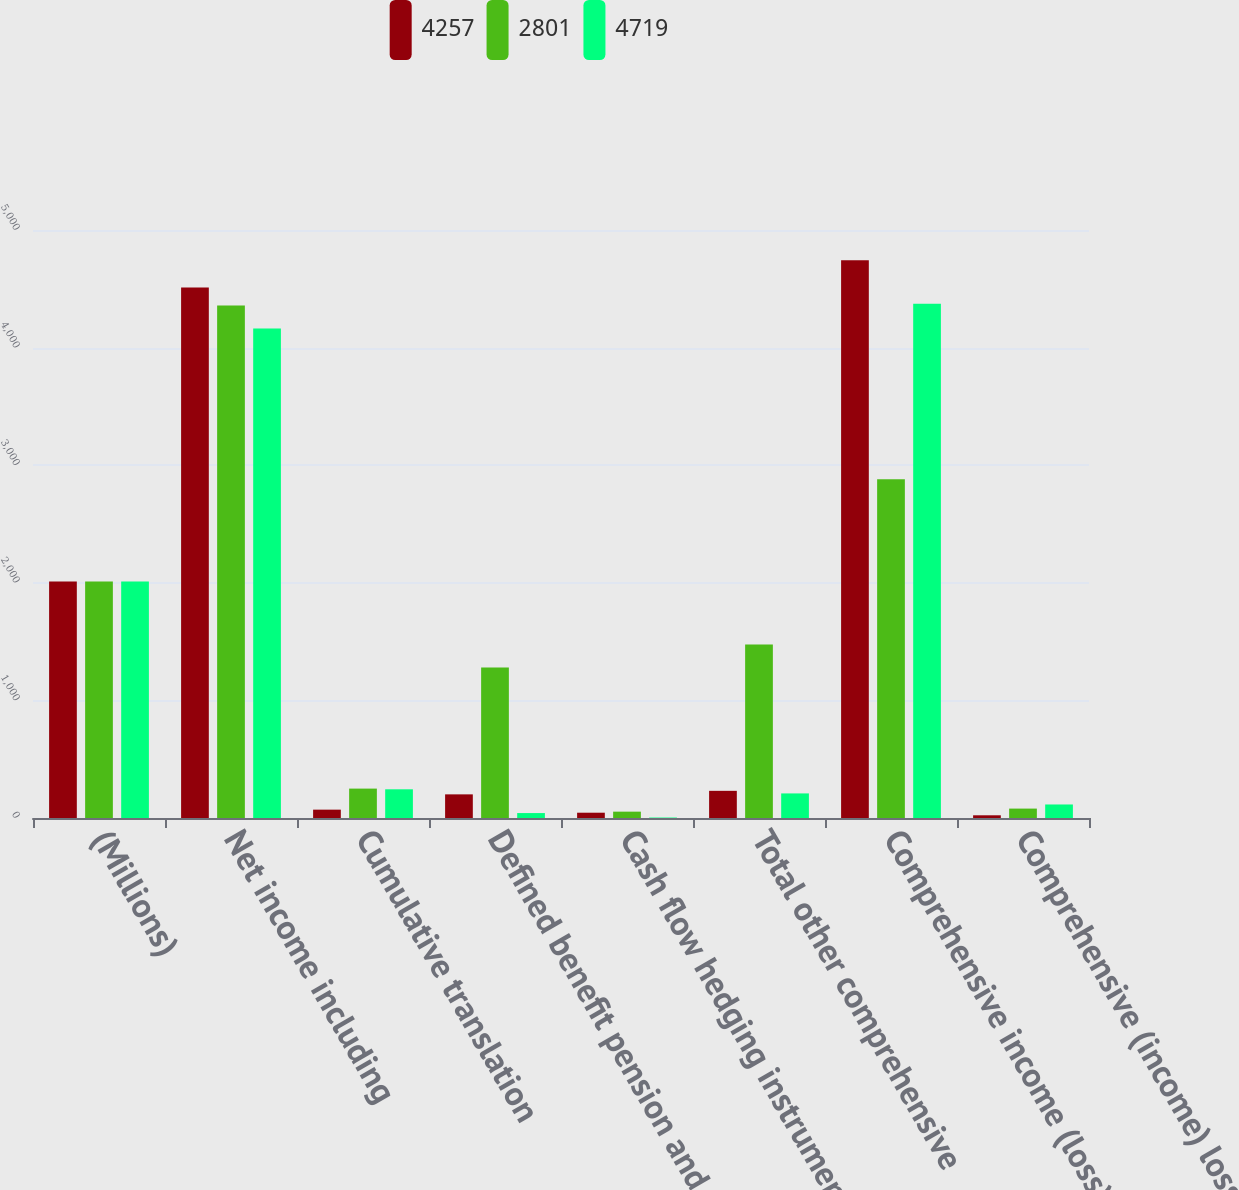Convert chart to OTSL. <chart><loc_0><loc_0><loc_500><loc_500><stacked_bar_chart><ecel><fcel>(Millions)<fcel>Net income including<fcel>Cumulative translation<fcel>Defined benefit pension and<fcel>Cash flow hedging instruments<fcel>Total other comprehensive<fcel>Comprehensive income (loss)<fcel>Comprehensive (income) loss<nl><fcel>4257<fcel>2012<fcel>4511<fcel>71<fcel>201<fcel>45<fcel>231<fcel>4742<fcel>23<nl><fcel>2801<fcel>2011<fcel>4357<fcel>250<fcel>1280<fcel>54<fcel>1476<fcel>2881<fcel>80<nl><fcel>4719<fcel>2010<fcel>4163<fcel>244<fcel>42<fcel>4<fcel>209<fcel>4372<fcel>115<nl></chart> 